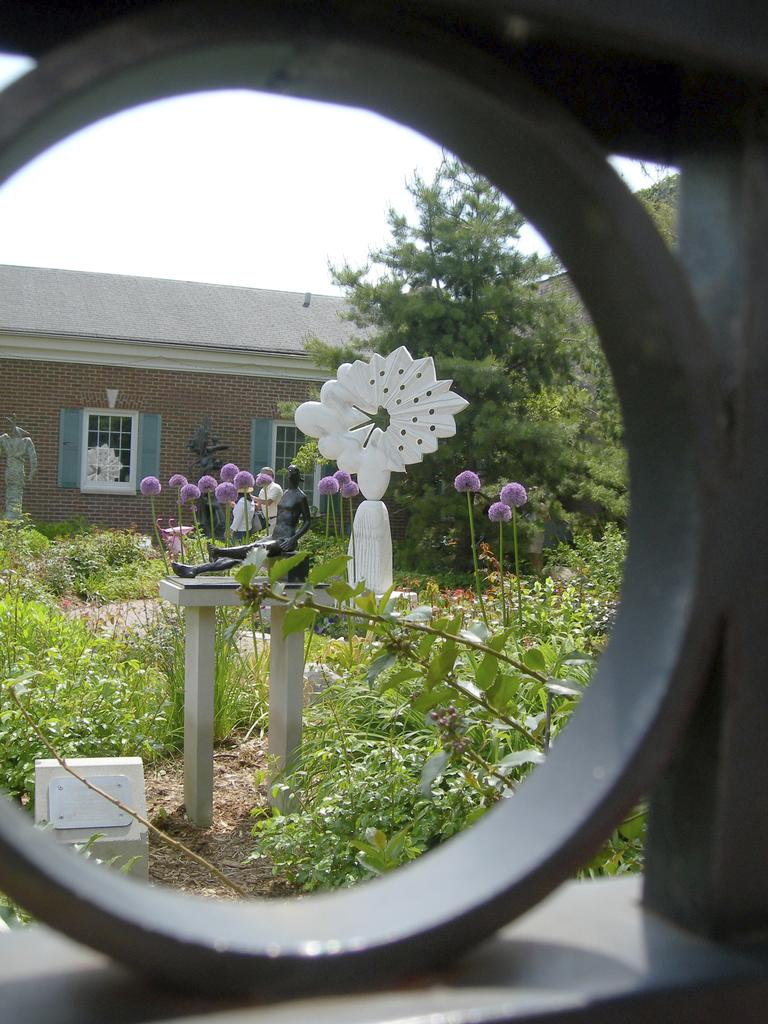What type of structure is present in the image? There is a house in the image. What feature can be seen on the house? The house has windows. What type of vegetation is present in the image? There are flowers, plants, and trees in the image. What is visible in the background of the image? The sky is visible in the image. What type of drink can be seen in the image? There is no drink present in the image. Can you describe the mist in the image? There is no mist present in the image. 